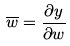<formula> <loc_0><loc_0><loc_500><loc_500>\overline { w } = \frac { \partial y } { \partial w }</formula> 